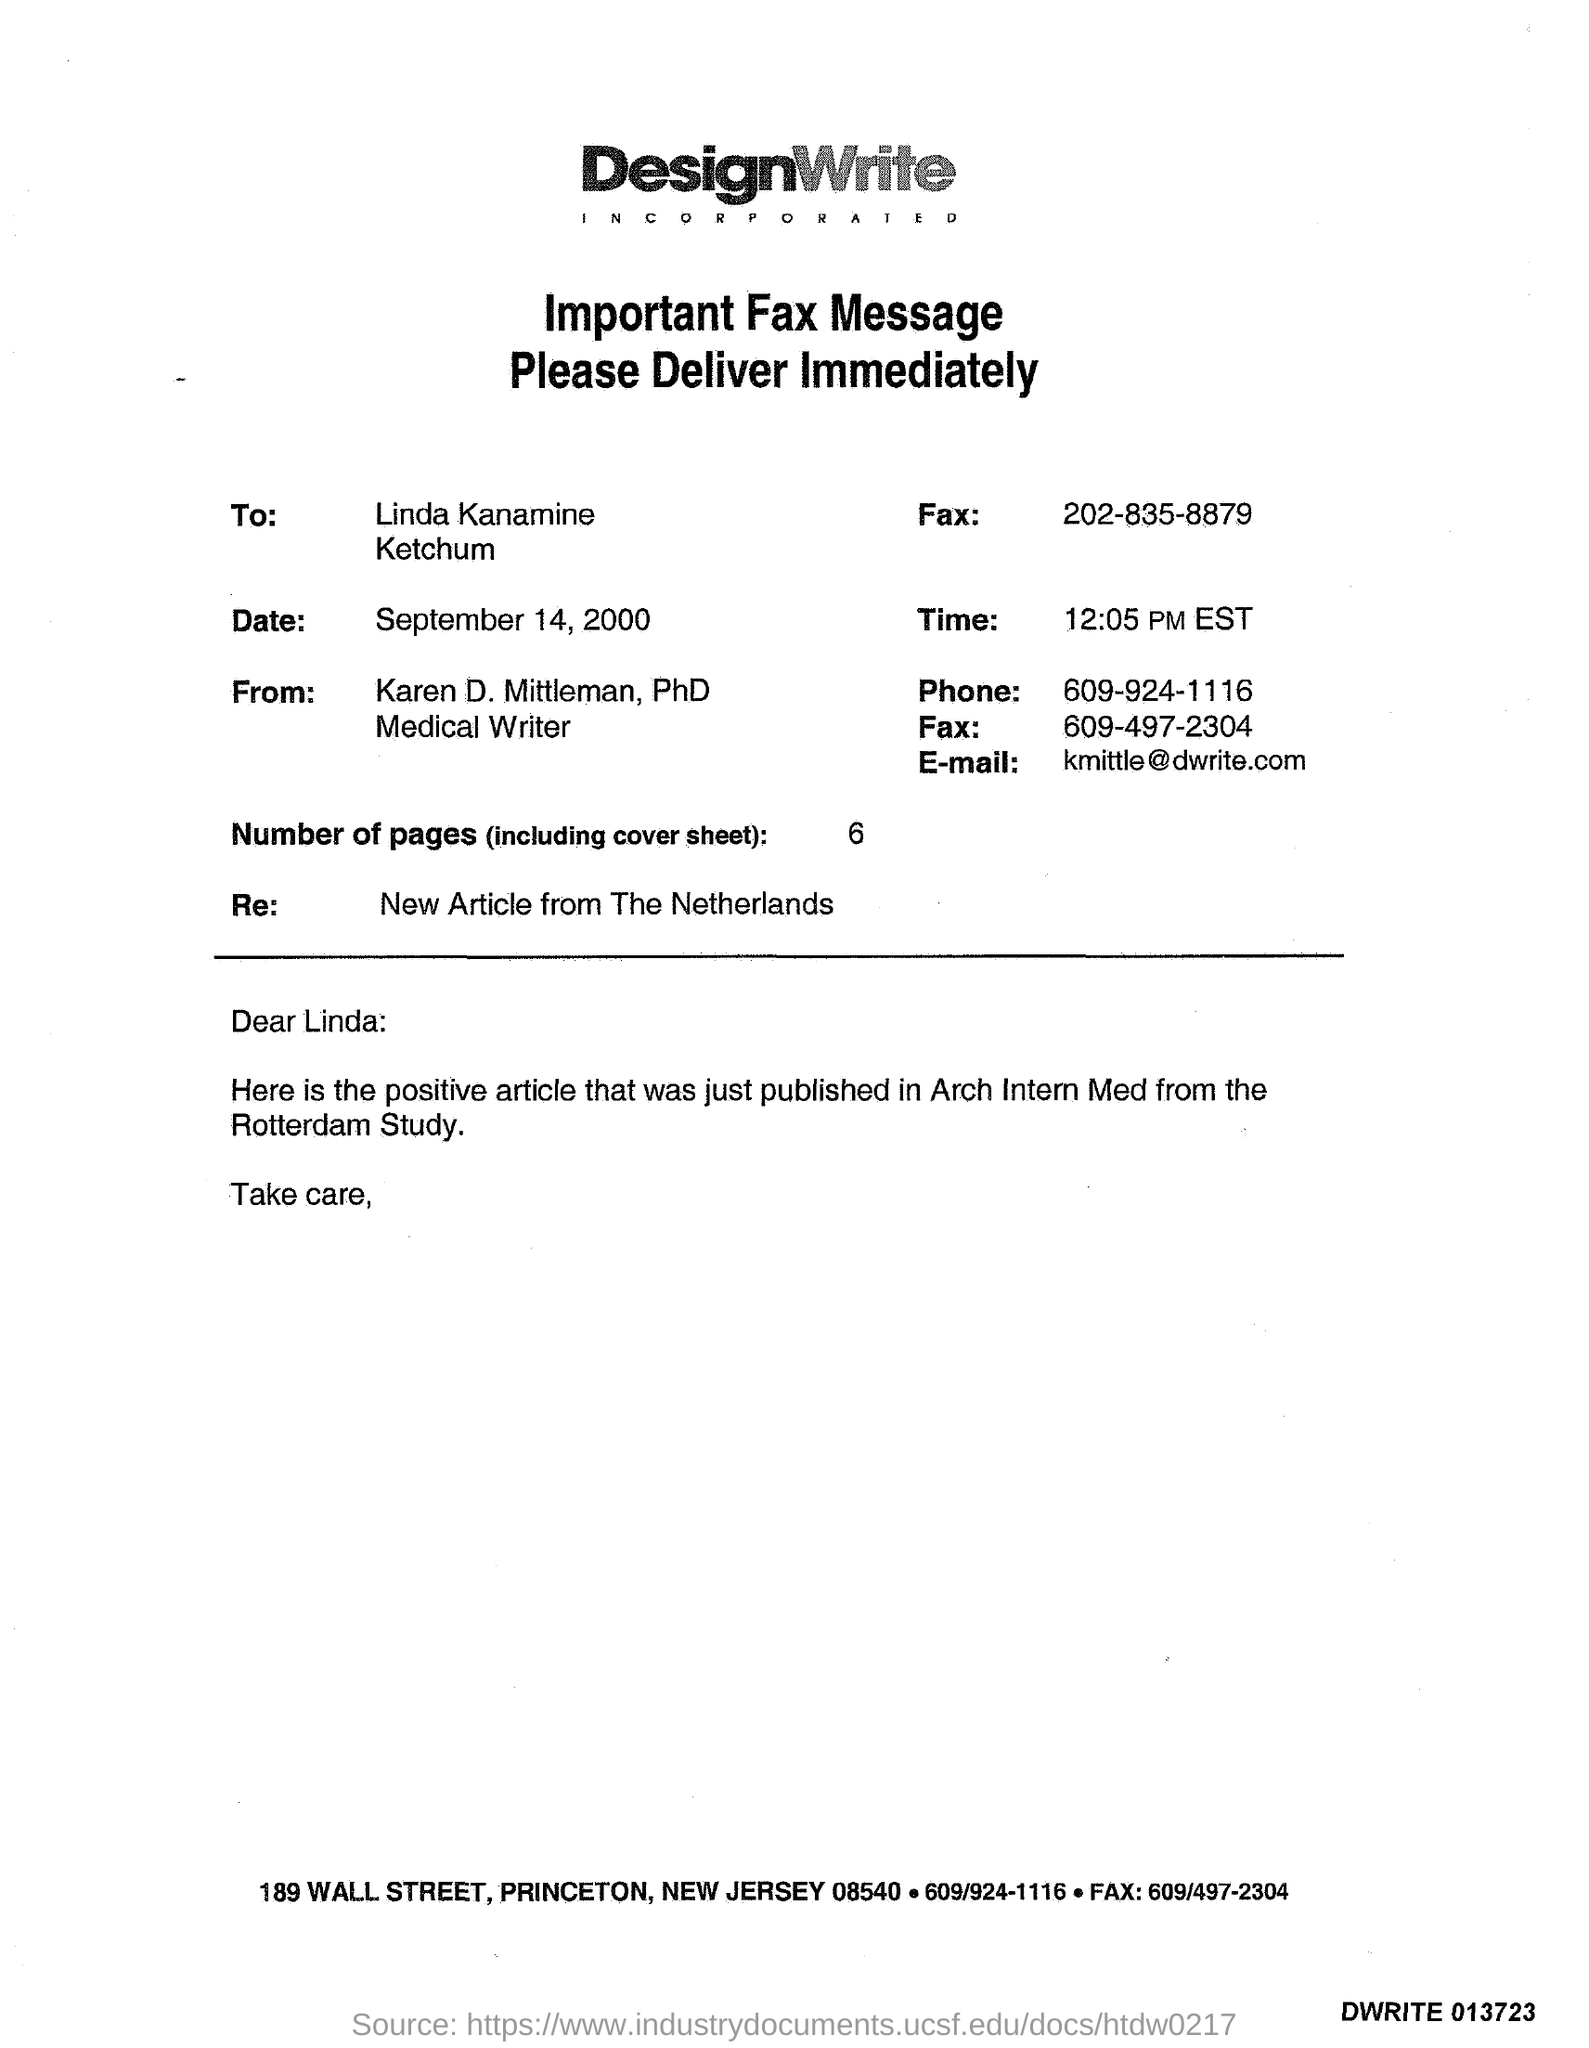List a handful of essential elements in this visual. Karen D. Mittleman can be contacted at [kmittle@dwrite.com](mailto:kmittle@dwrite.com). 